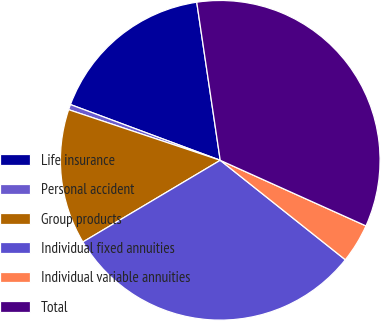<chart> <loc_0><loc_0><loc_500><loc_500><pie_chart><fcel>Life insurance<fcel>Personal accident<fcel>Group products<fcel>Individual fixed annuities<fcel>Individual variable annuities<fcel>Total<nl><fcel>16.98%<fcel>0.54%<fcel>13.67%<fcel>30.77%<fcel>3.96%<fcel>34.08%<nl></chart> 